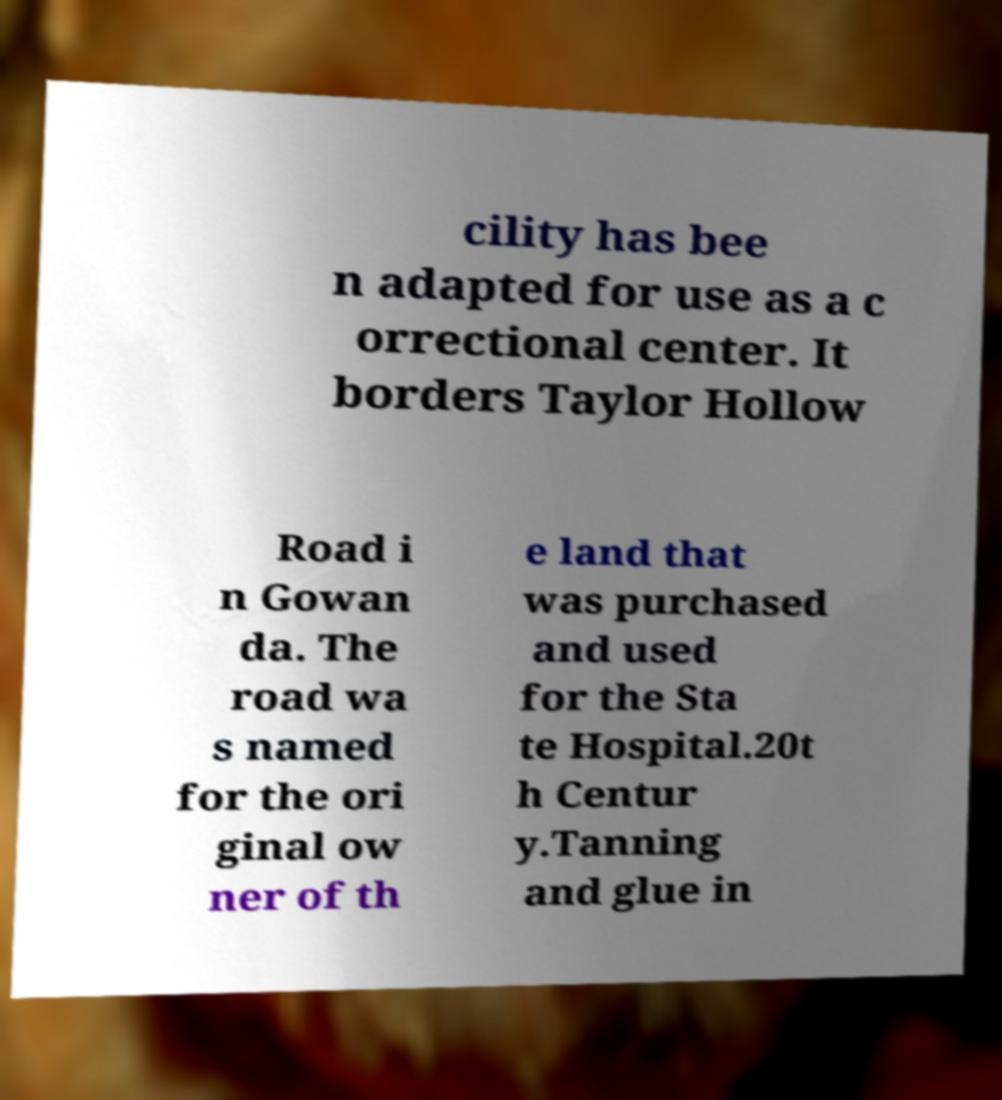I need the written content from this picture converted into text. Can you do that? cility has bee n adapted for use as a c orrectional center. It borders Taylor Hollow Road i n Gowan da. The road wa s named for the ori ginal ow ner of th e land that was purchased and used for the Sta te Hospital.20t h Centur y.Tanning and glue in 